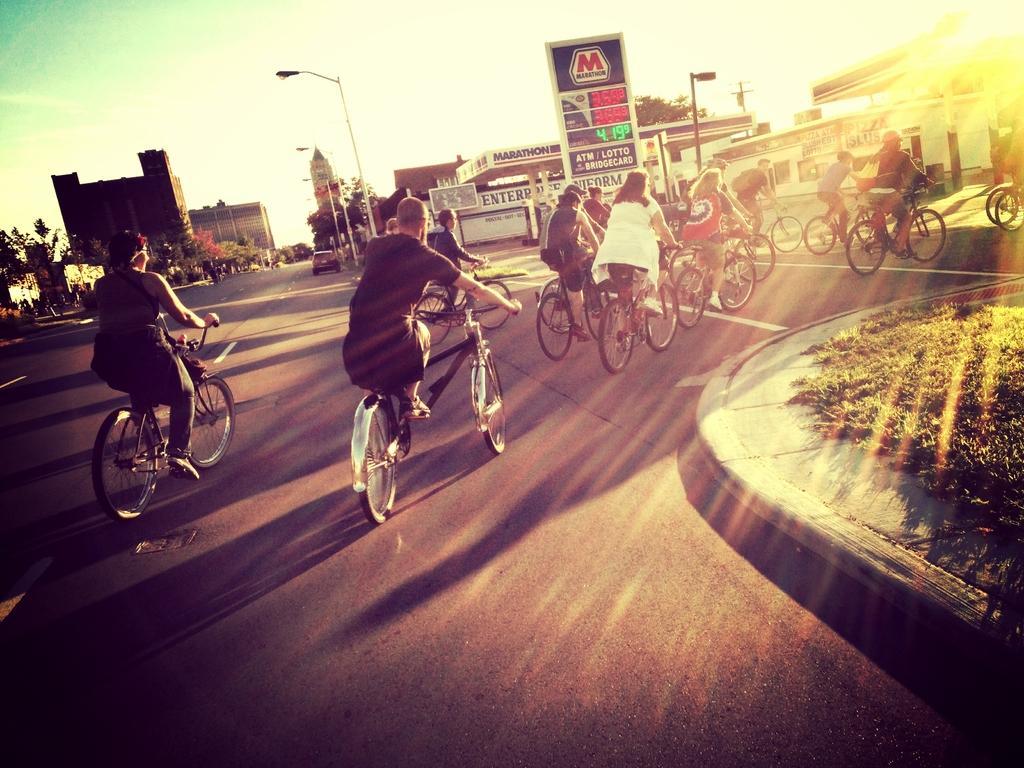Describe this image in one or two sentences. There are people riding bicycles on the road and we can see grass. In the background we can see buildings, lights on poles, board, car, trees and sky. 